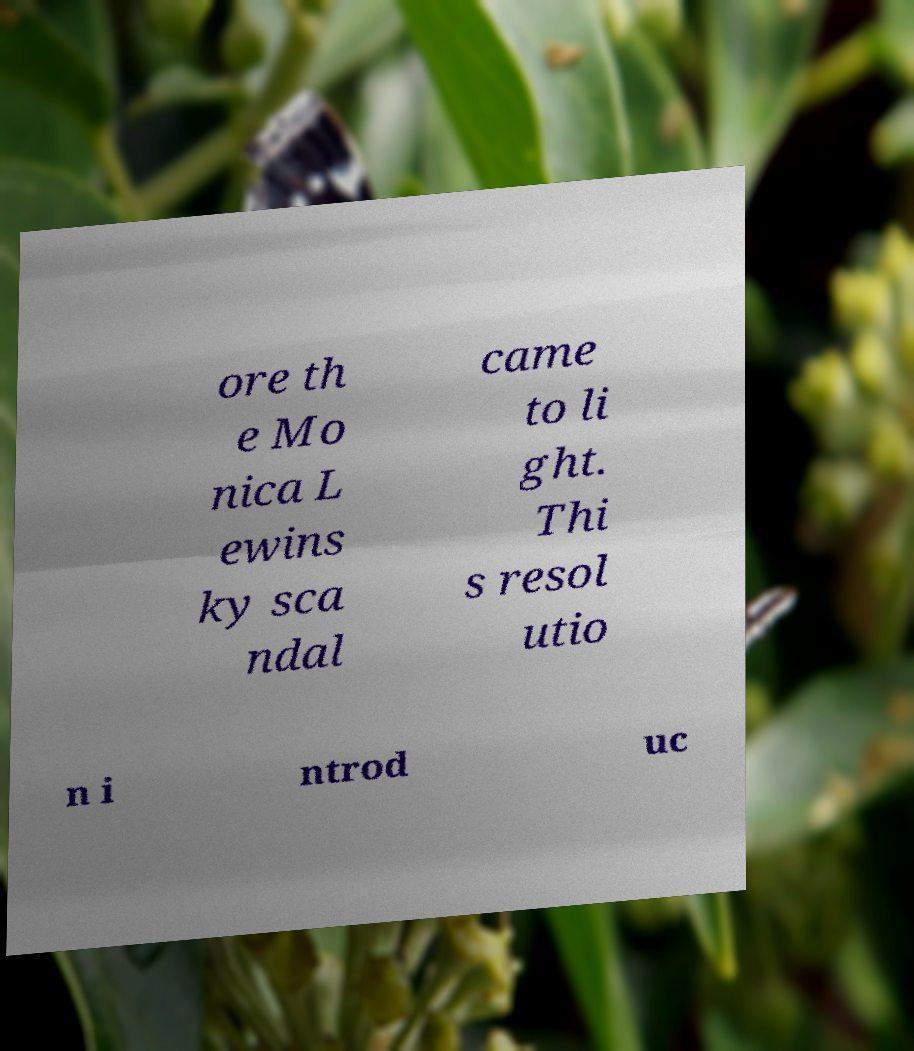Please read and relay the text visible in this image. What does it say? ore th e Mo nica L ewins ky sca ndal came to li ght. Thi s resol utio n i ntrod uc 